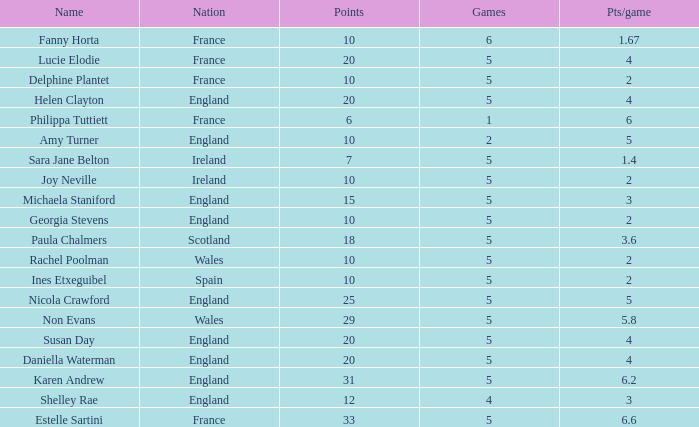Can you tell me the average Points that has a Pts/game larger than 4, and the Nation of england, and the Games smaller than 5? 10.0. 